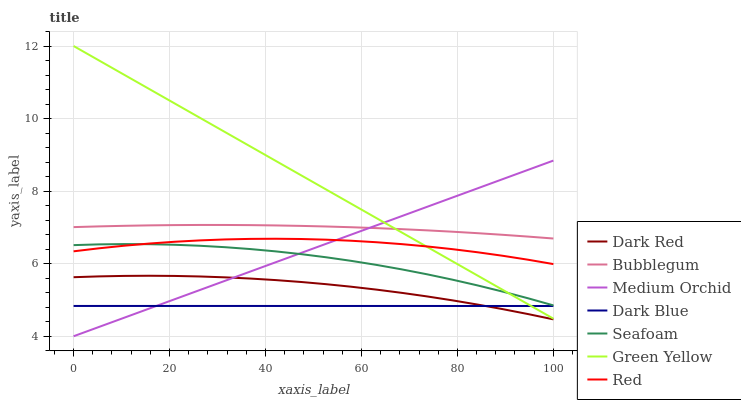Does Medium Orchid have the minimum area under the curve?
Answer yes or no. No. Does Medium Orchid have the maximum area under the curve?
Answer yes or no. No. Is Medium Orchid the smoothest?
Answer yes or no. No. Is Medium Orchid the roughest?
Answer yes or no. No. Does Seafoam have the lowest value?
Answer yes or no. No. Does Medium Orchid have the highest value?
Answer yes or no. No. Is Dark Red less than Red?
Answer yes or no. Yes. Is Red greater than Dark Red?
Answer yes or no. Yes. Does Dark Red intersect Red?
Answer yes or no. No. 